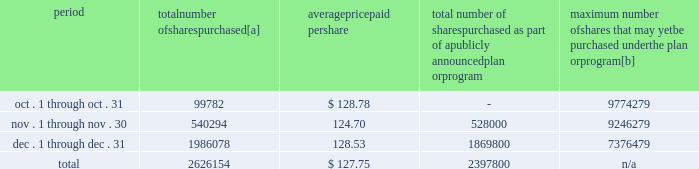Five-year performance comparison 2013 the following graph provides an indicator of cumulative total shareholder returns for the corporation as compared to the peer group index ( described above ) , the dow jones , and the s&p 500 .
The graph assumes that the value of the investment in the common stock of union pacific corporation and each index was $ 100 on december 31 , 2002 , and that all dividends were reinvested .
Comparison of five-year cumulative return 2002 2003 2004 2005 2006 2007 upc s&p 500 peer group dj trans purchases of equity securities 2013 during 2007 , we repurchased 13266070 shares of our common stock at an average price of $ 115.66 .
During the first nine months of 2007 , we repurchased 10639916 shares of our common stock at an average price per share of $ 112.68 .
The table presents common stock repurchases during each month for the fourth quarter of 2007 : period number of shares purchased average paid per total number of shares purchased as part of a publicly announced plan or program maximum number of shares that may yet be purchased under the plan or program .
[a] total number of shares purchased during the quarter includes 228354 shares delivered or attested to upc by employees to pay stock option exercise prices , satisfy excess tax withholding obligations for stock option exercises or vesting of retention units , and pay withholding obligations for vesting of retention shares .
[b] on january 30 , 2007 , our board of directors authorized us to repurchase up to 20 million shares of our common stock through december 31 , 2009 .
We may make these repurchases on the open market or through other transactions .
Our management has sole discretion with respect to determining the timing and amount of these transactions. .
What percentage of the total number of shares purchased were purchased in october? 
Computations: (99782 / 2626154)
Answer: 0.038. 